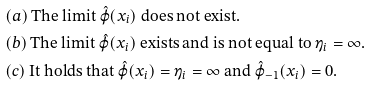Convert formula to latex. <formula><loc_0><loc_0><loc_500><loc_500>& ( a ) \, \text {The limit $\hat{\varphi}(x_{i})$ does not exist.} \\ & ( b ) \, \text {The limit $\hat{\varphi}(x_{i})$ exists and is not equal to $\eta_{i} = \infty$.} \\ & ( c ) \, \text {It holds that $\hat{\varphi}(x_{i}) = \eta_{i} = \infty$ and $\hat{\varphi}_{-1}(x_{i}) = 0$.}</formula> 